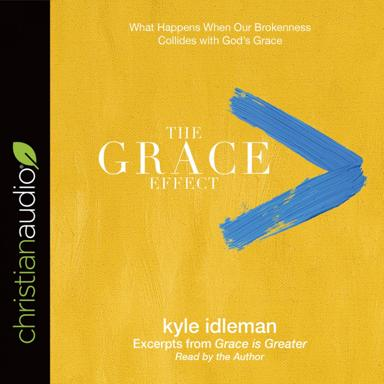What is the central theme of "The Grace Effect"? The central theme of "The Grace Effect," as anchored in the title and suggested by the image design, is an exploration of the profound change that occurs when human imperfection and struggles are met with divine grace. It delves into personal stories and theological insights that reveal the power of grace to heal, redeem, and uplift our lives, as narrated by Kyle Idleman. 